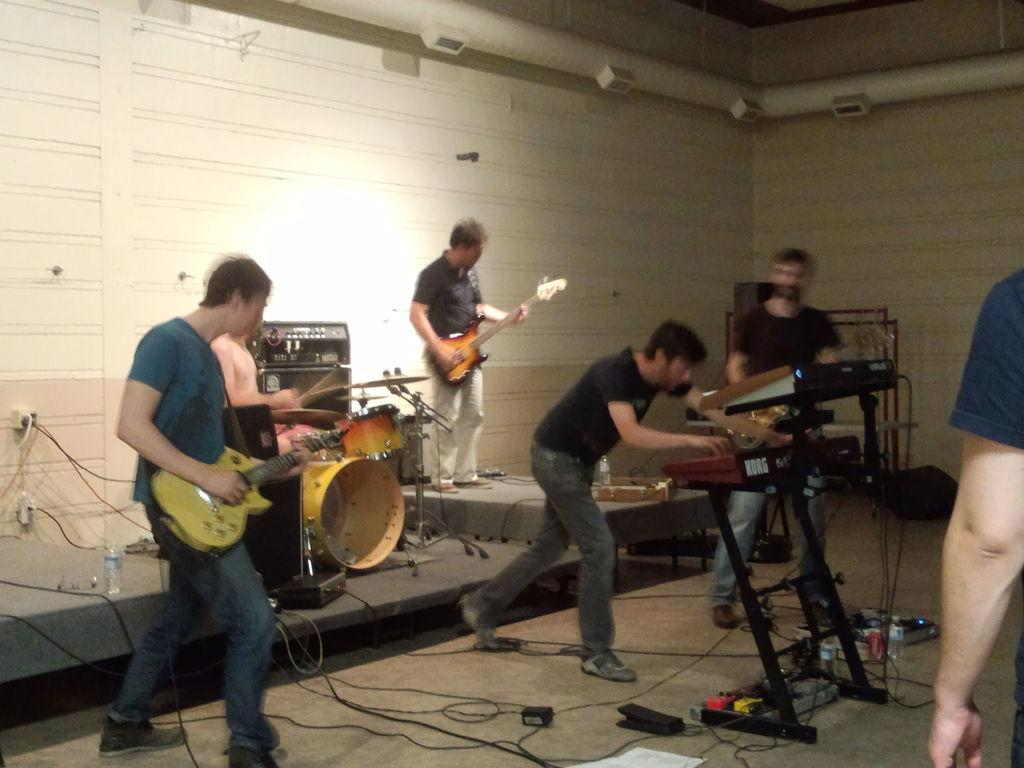How many people are in the image? There is a group of persons in the image. What are the persons in the image doing? The persons are playing musical instruments. What type of box can be seen in the image? There is no box present in the image; the image features a group of persons playing musical instruments. What kind of test is being conducted in the image? There is no test being conducted in the image; the image features a group of persons playing musical instruments. 